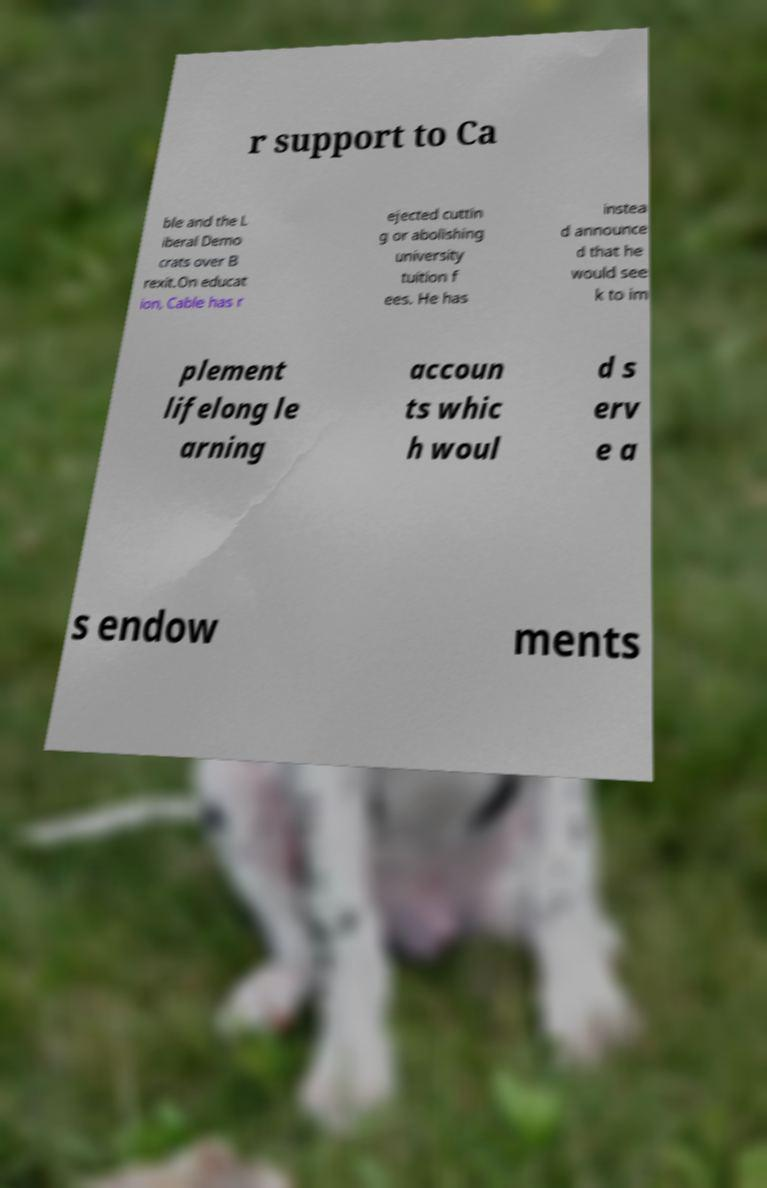Could you assist in decoding the text presented in this image and type it out clearly? r support to Ca ble and the L iberal Demo crats over B rexit.On educat ion, Cable has r ejected cuttin g or abolishing university tuition f ees. He has instea d announce d that he would see k to im plement lifelong le arning accoun ts whic h woul d s erv e a s endow ments 